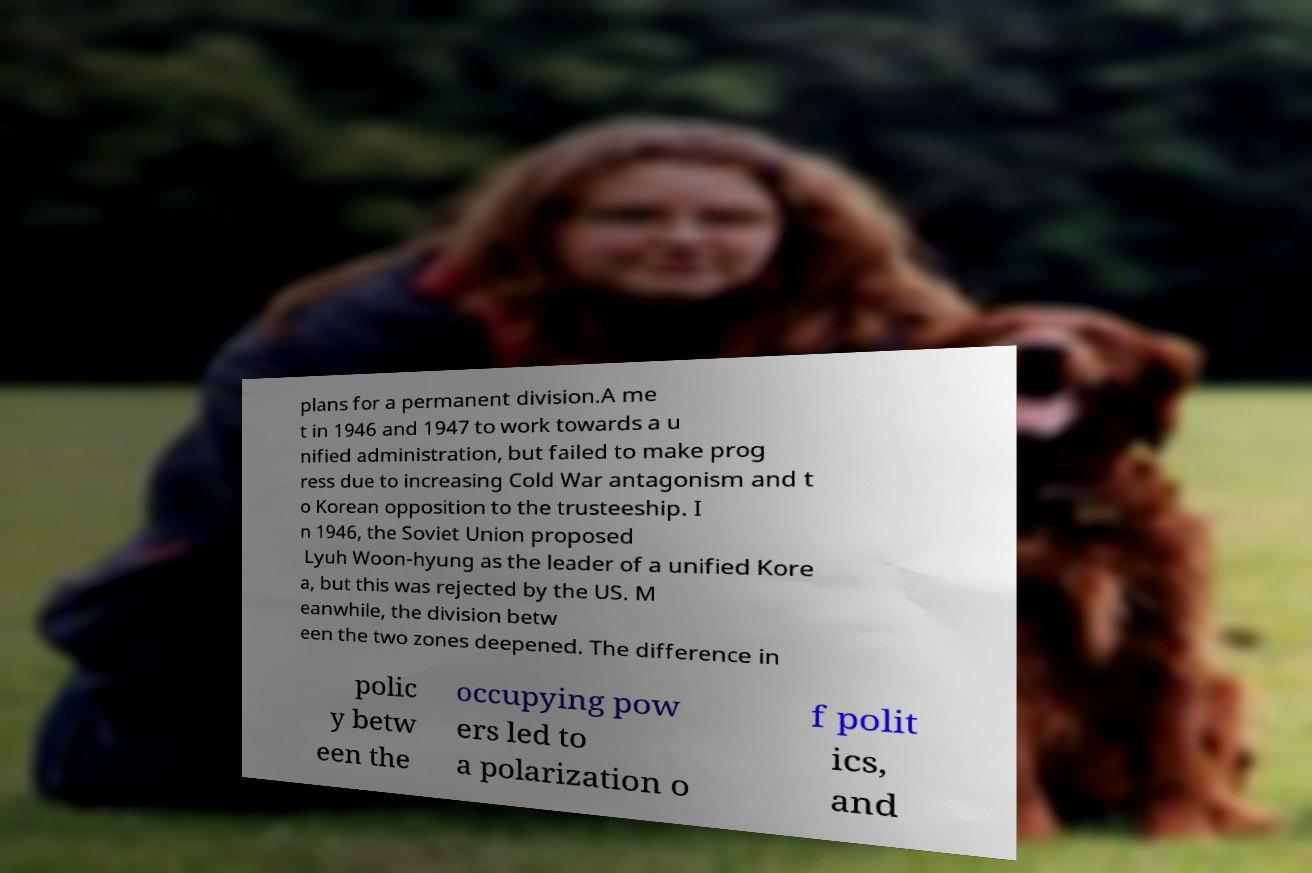Could you assist in decoding the text presented in this image and type it out clearly? plans for a permanent division.A me t in 1946 and 1947 to work towards a u nified administration, but failed to make prog ress due to increasing Cold War antagonism and t o Korean opposition to the trusteeship. I n 1946, the Soviet Union proposed Lyuh Woon-hyung as the leader of a unified Kore a, but this was rejected by the US. M eanwhile, the division betw een the two zones deepened. The difference in polic y betw een the occupying pow ers led to a polarization o f polit ics, and 